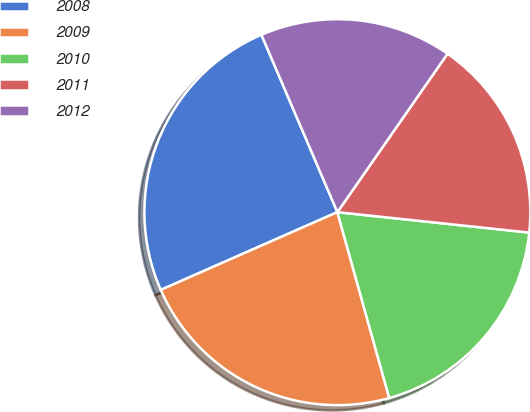Convert chart to OTSL. <chart><loc_0><loc_0><loc_500><loc_500><pie_chart><fcel>2008<fcel>2009<fcel>2010<fcel>2011<fcel>2012<nl><fcel>25.16%<fcel>22.73%<fcel>18.98%<fcel>17.02%<fcel>16.11%<nl></chart> 